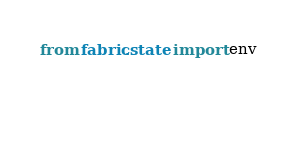Convert code to text. <code><loc_0><loc_0><loc_500><loc_500><_Python_>
from fabric.state import env

    



</code> 